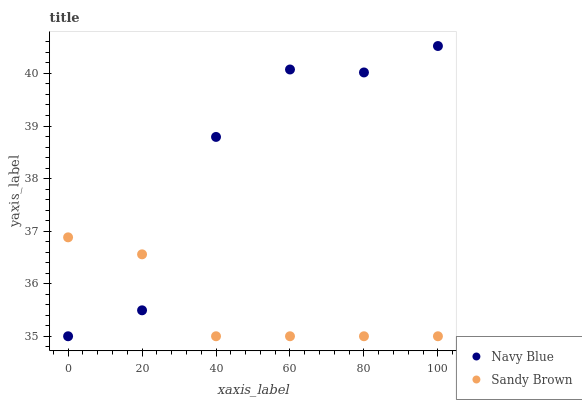Does Sandy Brown have the minimum area under the curve?
Answer yes or no. Yes. Does Navy Blue have the maximum area under the curve?
Answer yes or no. Yes. Does Sandy Brown have the maximum area under the curve?
Answer yes or no. No. Is Sandy Brown the smoothest?
Answer yes or no. Yes. Is Navy Blue the roughest?
Answer yes or no. Yes. Is Sandy Brown the roughest?
Answer yes or no. No. Does Navy Blue have the lowest value?
Answer yes or no. Yes. Does Navy Blue have the highest value?
Answer yes or no. Yes. Does Sandy Brown have the highest value?
Answer yes or no. No. Does Sandy Brown intersect Navy Blue?
Answer yes or no. Yes. Is Sandy Brown less than Navy Blue?
Answer yes or no. No. Is Sandy Brown greater than Navy Blue?
Answer yes or no. No. 